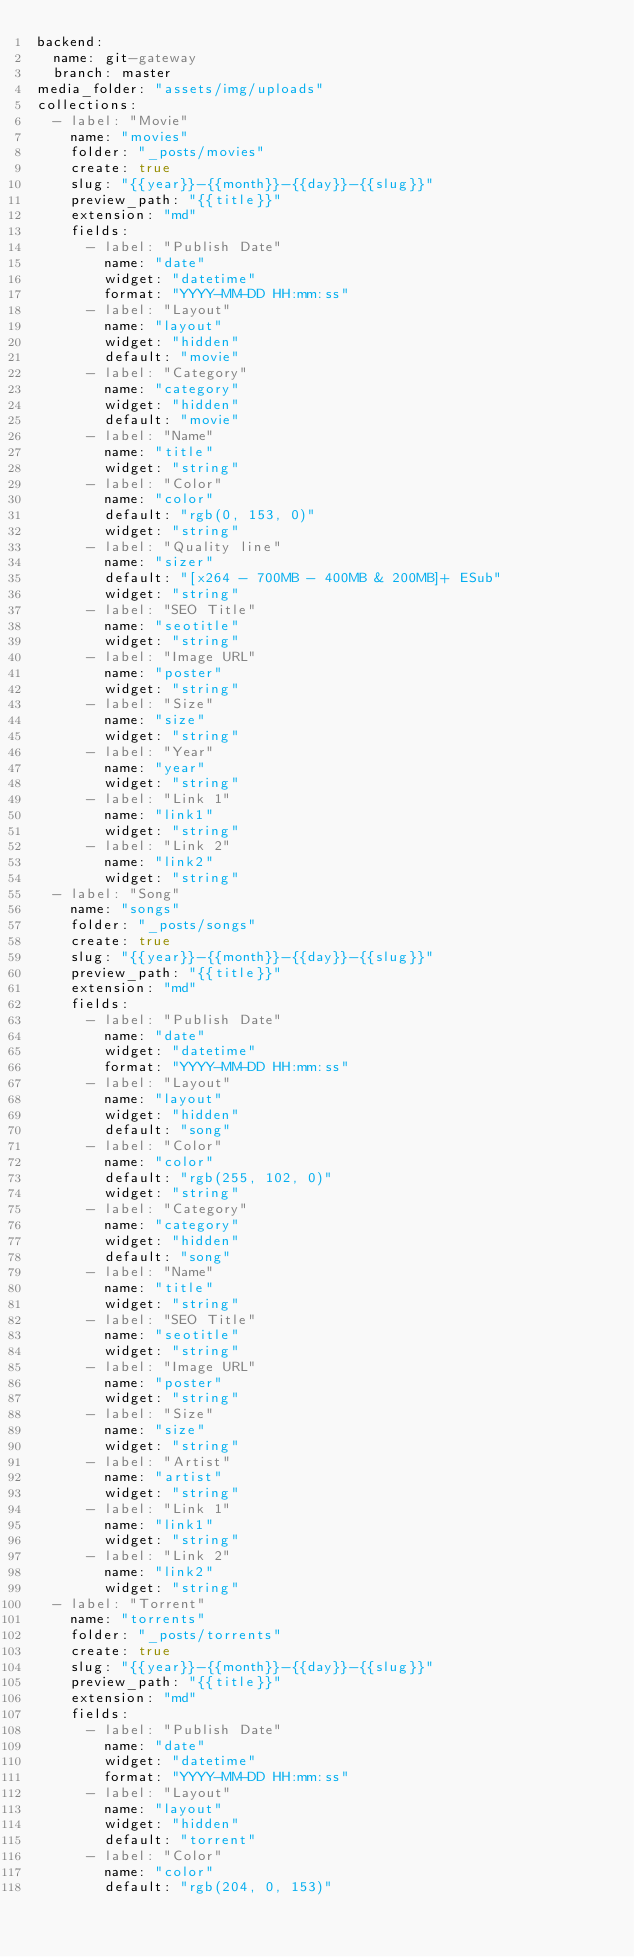<code> <loc_0><loc_0><loc_500><loc_500><_YAML_>backend:
  name: git-gateway
  branch: master
media_folder: "assets/img/uploads"
collections:
  - label: "Movie"
    name: "movies"
    folder: "_posts/movies"
    create: true
    slug: "{{year}}-{{month}}-{{day}}-{{slug}}"
    preview_path: "{{title}}"
    extension: "md"
    fields:
      - label: "Publish Date"
        name: "date"
        widget: "datetime"
        format: "YYYY-MM-DD HH:mm:ss"
      - label: "Layout"
        name: "layout"
        widget: "hidden"
        default: "movie"
      - label: "Category"
        name: "category"
        widget: "hidden"
        default: "movie"
      - label: "Name"
        name: "title"
        widget: "string"
      - label: "Color"
        name: "color"
        default: "rgb(0, 153, 0)"
        widget: "string"
      - label: "Quality line"
        name: "sizer"
        default: "[x264 - 700MB - 400MB & 200MB]+ ESub"
        widget: "string"
      - label: "SEO Title"
        name: "seotitle"
        widget: "string"
      - label: "Image URL"
        name: "poster"
        widget: "string"
      - label: "Size"
        name: "size"
        widget: "string"
      - label: "Year"
        name: "year"
        widget: "string"
      - label: "Link 1"
        name: "link1"
        widget: "string"
      - label: "Link 2"
        name: "link2"
        widget: "string"
  - label: "Song"
    name: "songs"
    folder: "_posts/songs"
    create: true
    slug: "{{year}}-{{month}}-{{day}}-{{slug}}"
    preview_path: "{{title}}"
    extension: "md"
    fields:
      - label: "Publish Date"
        name: "date"
        widget: "datetime"
        format: "YYYY-MM-DD HH:mm:ss"
      - label: "Layout"
        name: "layout"
        widget: "hidden"
        default: "song"
      - label: "Color"
        name: "color"
        default: "rgb(255, 102, 0)"
        widget: "string"
      - label: "Category"
        name: "category"
        widget: "hidden"
        default: "song"
      - label: "Name"
        name: "title"
        widget: "string"
      - label: "SEO Title"
        name: "seotitle"
        widget: "string"
      - label: "Image URL"
        name: "poster"
        widget: "string"
      - label: "Size"
        name: "size"
        widget: "string"
      - label: "Artist"
        name: "artist"
        widget: "string"
      - label: "Link 1"
        name: "link1"
        widget: "string"
      - label: "Link 2"
        name: "link2"
        widget: "string"
  - label: "Torrent"
    name: "torrents"
    folder: "_posts/torrents"
    create: true
    slug: "{{year}}-{{month}}-{{day}}-{{slug}}"
    preview_path: "{{title}}"
    extension: "md"
    fields:
      - label: "Publish Date"
        name: "date"
        widget: "datetime"
        format: "YYYY-MM-DD HH:mm:ss"
      - label: "Layout"
        name: "layout"
        widget: "hidden"
        default: "torrent"
      - label: "Color"
        name: "color"
        default: "rgb(204, 0, 153)"</code> 